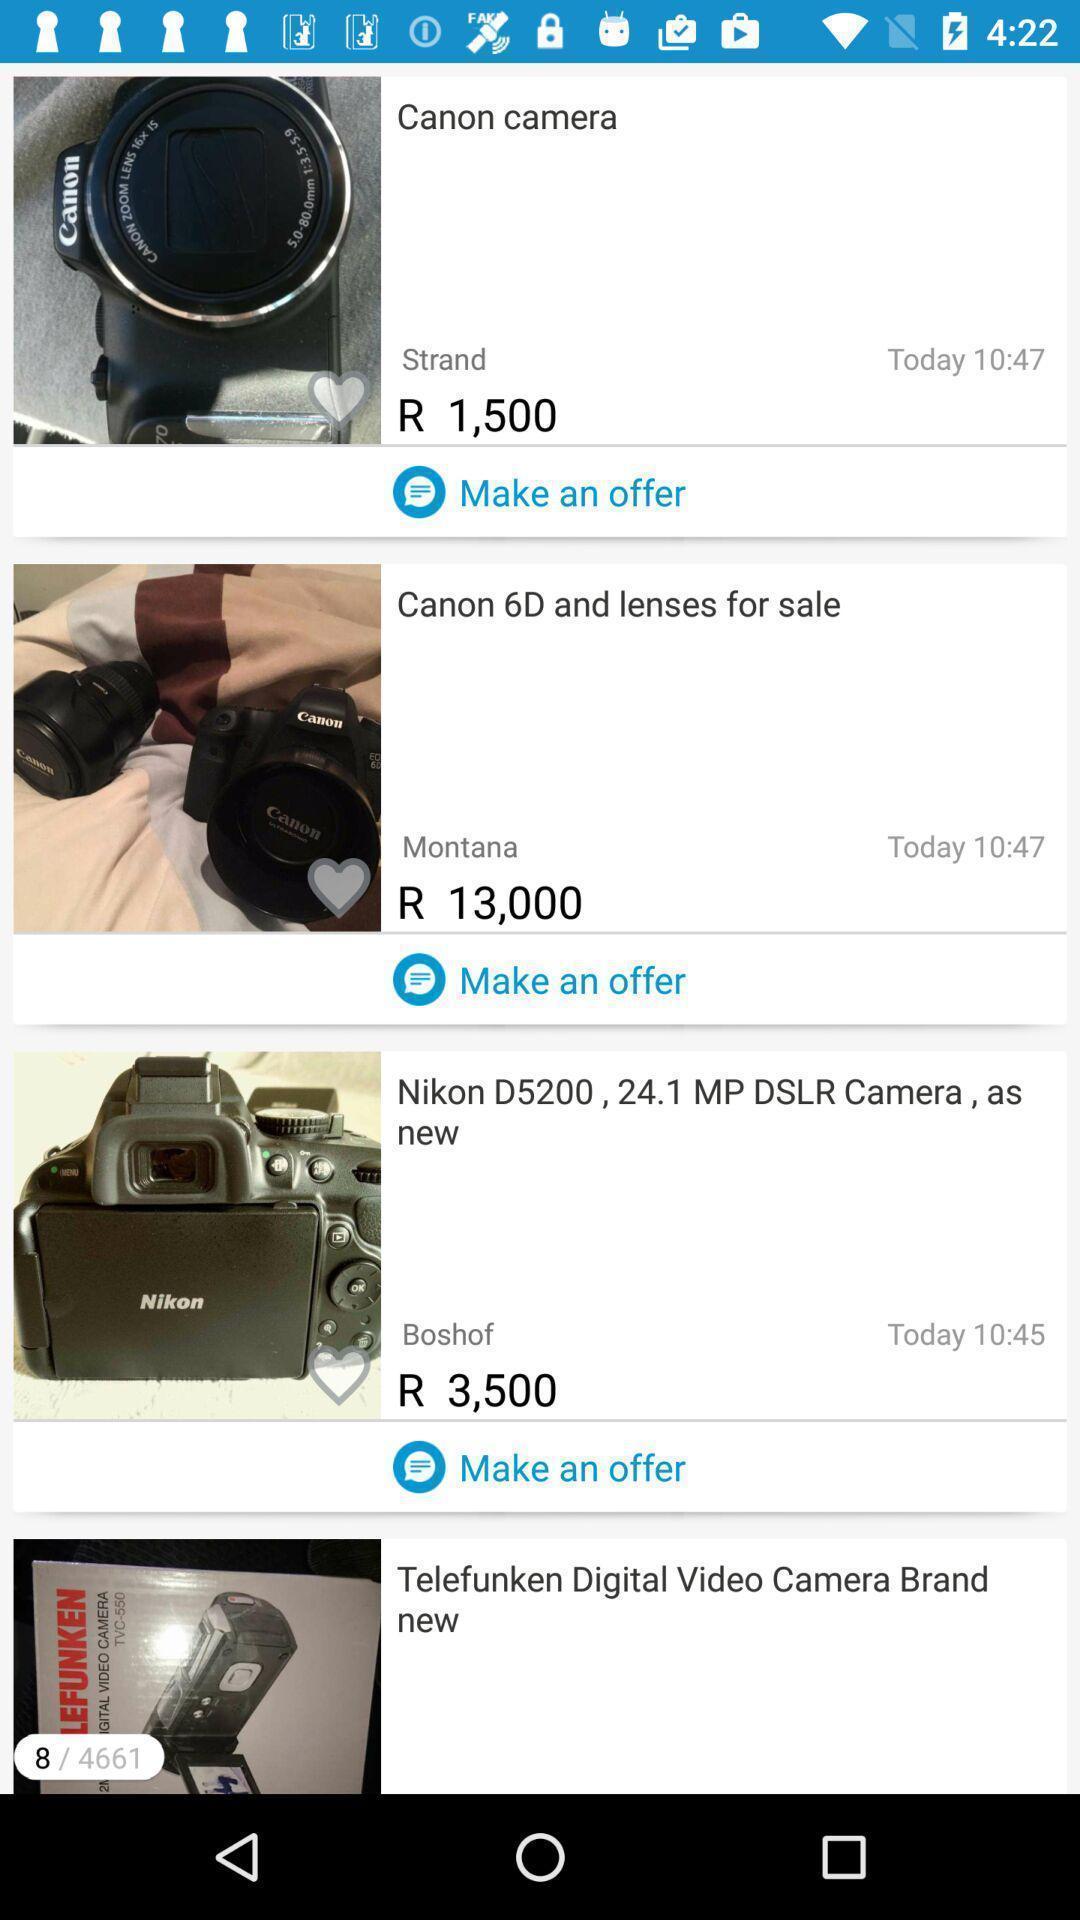Give me a summary of this screen capture. Screen displaying the page of an online market app. 